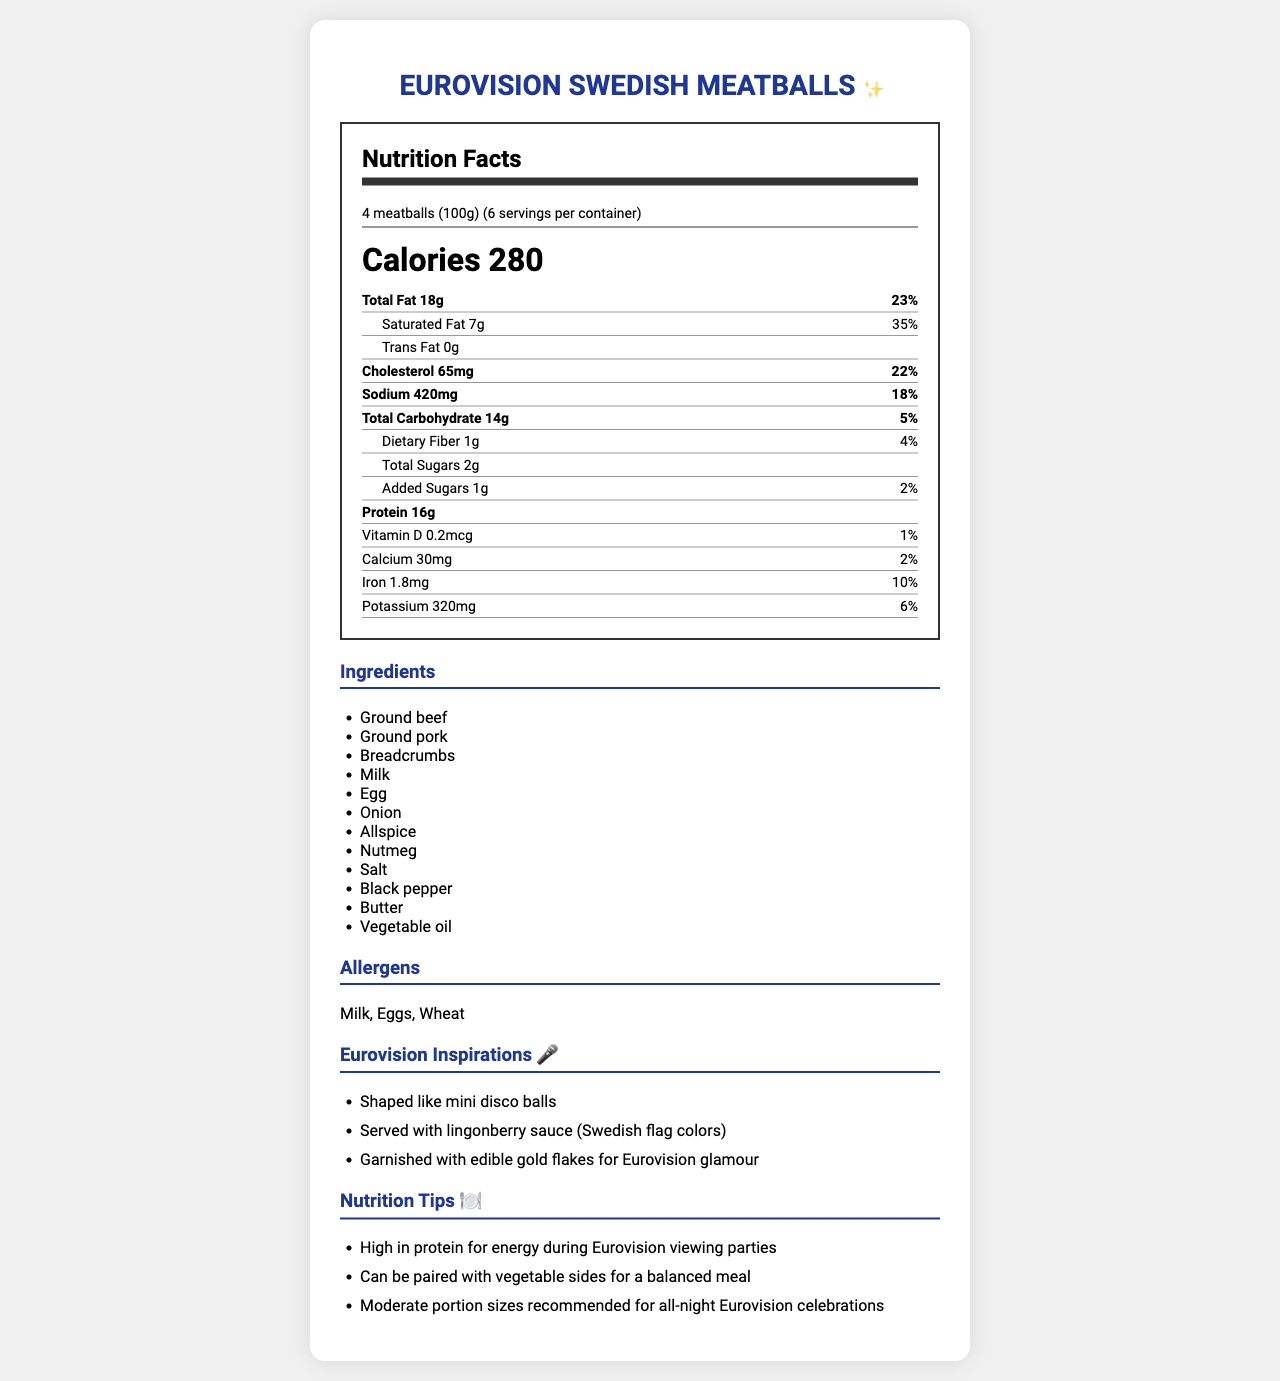what is the serving size? The serving size is clearly mentioned as "4 meatballs (100g)" in the serving info section at the top of the nutrition label.
Answer: 4 meatballs (100g) how many calories are in one serving? The nutrition label specifies that there are 280 calories per serving.
Answer: 280 what percentage of the daily value for saturated fat does one serving provide? The label shows that one serving contains 7g of saturated fat, which is 35% of the daily value.
Answer: 35% what are the main ingredients in the Swedish meatballs? The ingredients list all the main components used in the recipe.
Answer: Ground beef, Ground pork, Breadcrumbs, Milk, Egg, Onion, Allspice, Nutmeg, Salt, Black pepper, Butter, Vegetable oil how much protein does one serving contain? The document mentions that each serving of 4 meatballs contains 16g of protein.
Answer: 16g which of the following is NOT an allergen listed in the document? A. Milk B. Eggs C. Peanuts D. Wheat The allergens listed in the document are Milk, Eggs, and Wheat. Peanuts are not listed as an allergen.
Answer: C. Peanuts how many servings are there per container? The serving info section states that there are 6 servings per container.
Answer: 6 what unique feature is included in the Eurovision meatballs presentation? A. Shaped like mini disco balls B. Served with raspberry sauce C. Garnished with edible silver flakes According to the Eurovision Inspirations section, the meatballs are presented "Shaped like mini disco balls".
Answer: A. Shaped like mini disco balls does one serving contain any trans fat? The nutrition label indicates that there is 0g of trans fat per serving.
Answer: No summarize the main idea of the document. The document includes detailed nutrition information such as calories, macronutrients, and vitamins, lists the ingredients and allergens, and highlights creative Eurovision-inspired presentation ideas for the meatballs.
Answer: The document provides the nutrition facts, ingredients, allergens, and Eurovision inspirations for a traditional Swedish meatball recipe, emphasizing its presentation and nutritional benefits. who is the manufacturer of the meatballs? The document does not provide any information about the manufacturer of the meatballs.
Answer: Cannot be determined 